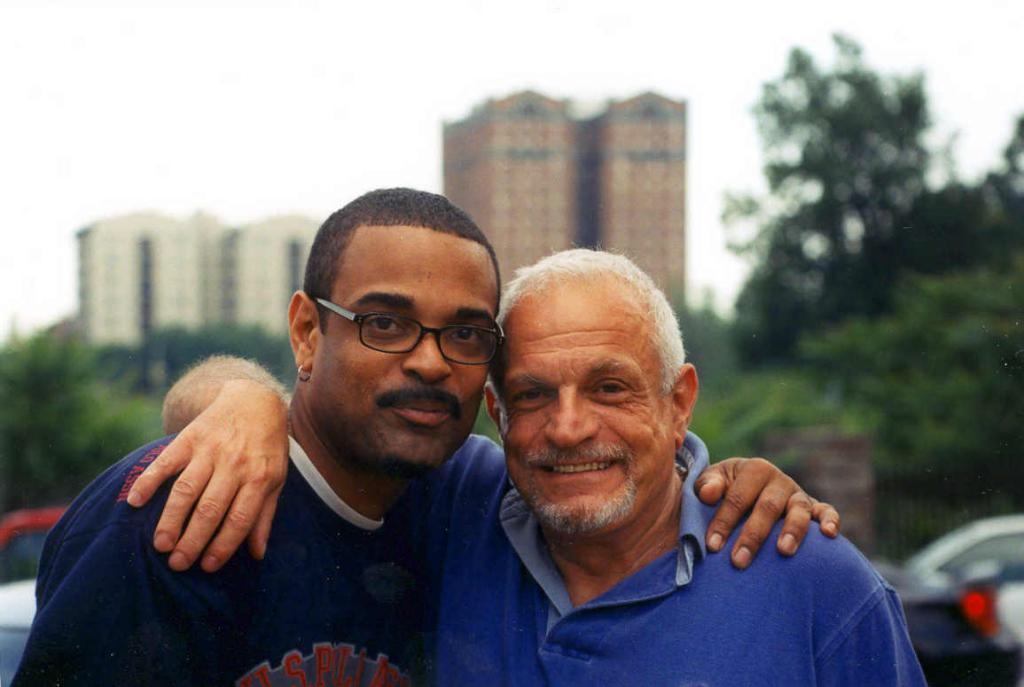Could you give a brief overview of what you see in this image? In this image I can see two persons wearing blue colored dresses and I can see one of them is wearing spectacles. In the background I can see few vehicles, few trees, few buildings and the sky. 